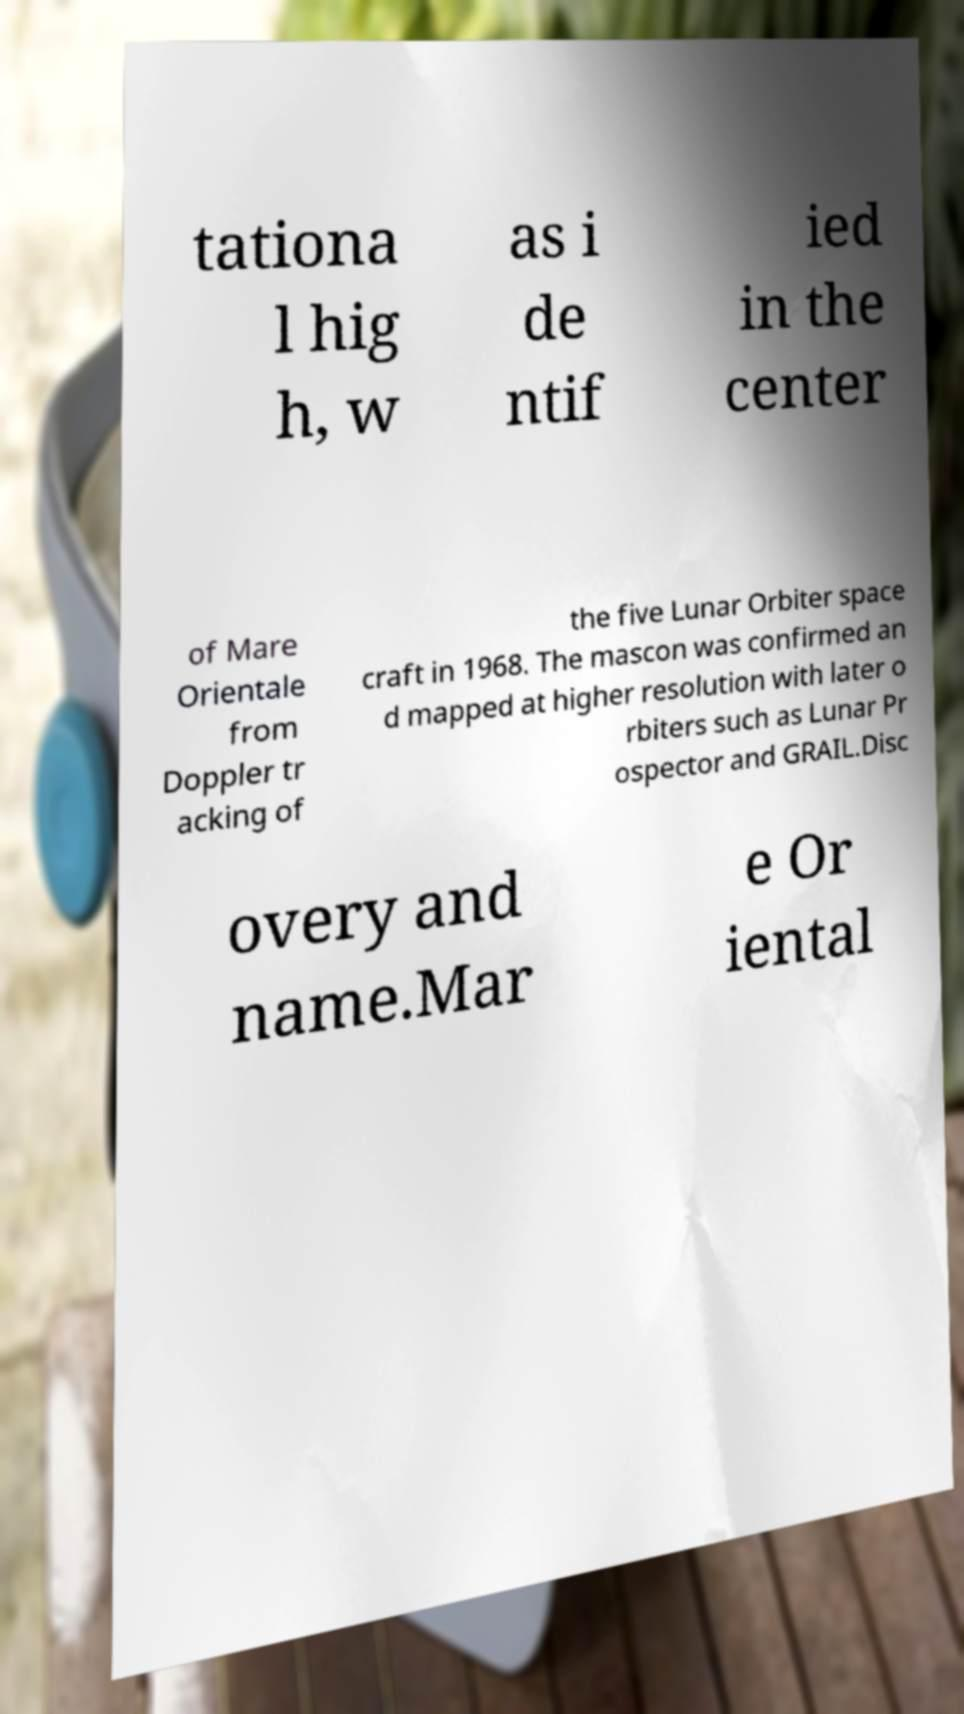There's text embedded in this image that I need extracted. Can you transcribe it verbatim? tationa l hig h, w as i de ntif ied in the center of Mare Orientale from Doppler tr acking of the five Lunar Orbiter space craft in 1968. The mascon was confirmed an d mapped at higher resolution with later o rbiters such as Lunar Pr ospector and GRAIL.Disc overy and name.Mar e Or iental 